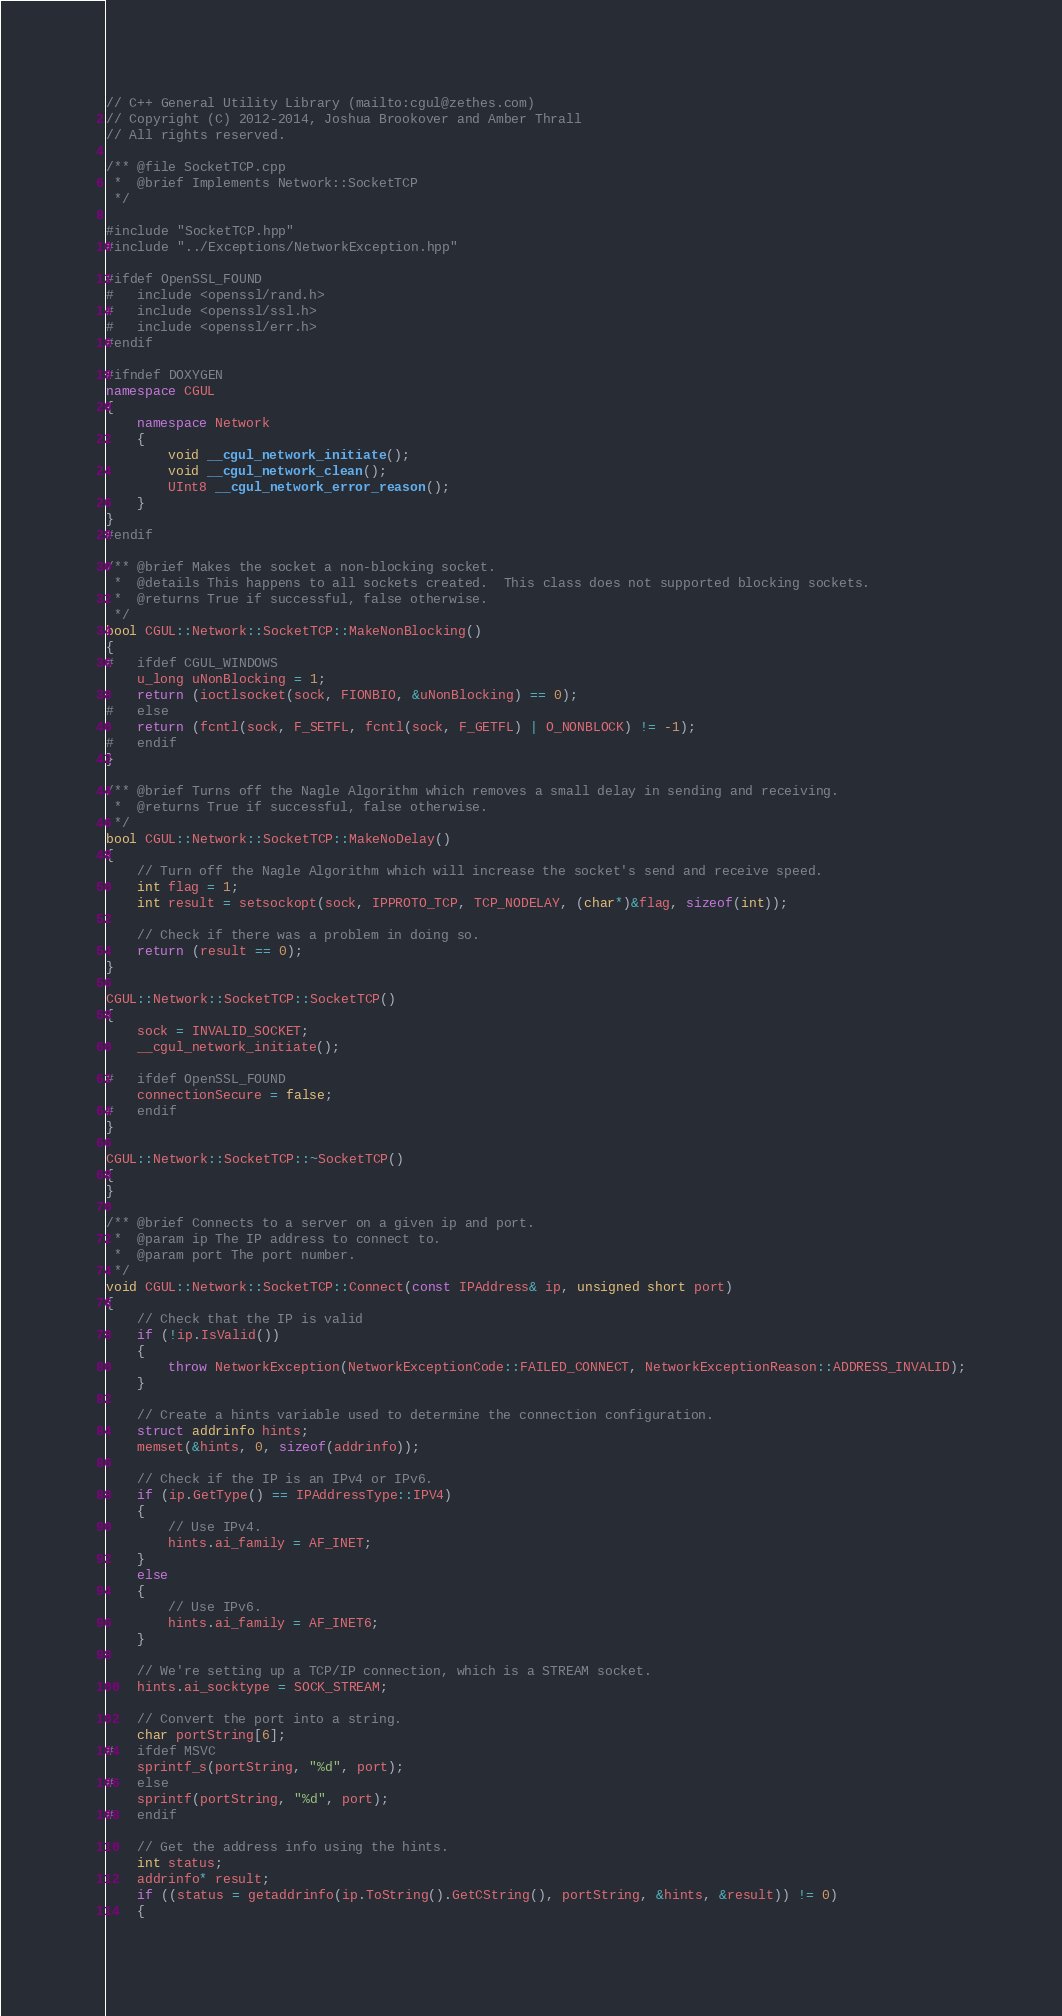<code> <loc_0><loc_0><loc_500><loc_500><_C++_>// C++ General Utility Library (mailto:cgul@zethes.com)
// Copyright (C) 2012-2014, Joshua Brookover and Amber Thrall
// All rights reserved.

/** @file SocketTCP.cpp
 *  @brief Implements Network::SocketTCP
 */

#include "SocketTCP.hpp"
#include "../Exceptions/NetworkException.hpp"

#ifdef OpenSSL_FOUND
#   include <openssl/rand.h>
#   include <openssl/ssl.h>
#   include <openssl/err.h>
#endif

#ifndef DOXYGEN
namespace CGUL
{
    namespace Network
    {
        void __cgul_network_initiate();
        void __cgul_network_clean();
        UInt8 __cgul_network_error_reason();
    }
}
#endif

/** @brief Makes the socket a non-blocking socket.
 *  @details This happens to all sockets created.  This class does not supported blocking sockets.
 *  @returns True if successful, false otherwise.
 */
bool CGUL::Network::SocketTCP::MakeNonBlocking()
{
#   ifdef CGUL_WINDOWS
    u_long uNonBlocking = 1;
    return (ioctlsocket(sock, FIONBIO, &uNonBlocking) == 0);
#   else
    return (fcntl(sock, F_SETFL, fcntl(sock, F_GETFL) | O_NONBLOCK) != -1);
#   endif
}

/** @brief Turns off the Nagle Algorithm which removes a small delay in sending and receiving.
 *  @returns True if successful, false otherwise.
 */
bool CGUL::Network::SocketTCP::MakeNoDelay()
{
    // Turn off the Nagle Algorithm which will increase the socket's send and receive speed.
    int flag = 1;
    int result = setsockopt(sock, IPPROTO_TCP, TCP_NODELAY, (char*)&flag, sizeof(int));

    // Check if there was a problem in doing so.
    return (result == 0);
}

CGUL::Network::SocketTCP::SocketTCP()
{
    sock = INVALID_SOCKET;
    __cgul_network_initiate();

#   ifdef OpenSSL_FOUND
    connectionSecure = false;
#   endif
}

CGUL::Network::SocketTCP::~SocketTCP()
{
}

/** @brief Connects to a server on a given ip and port.
 *  @param ip The IP address to connect to.
 *  @param port The port number.
 */
void CGUL::Network::SocketTCP::Connect(const IPAddress& ip, unsigned short port)
{
    // Check that the IP is valid
    if (!ip.IsValid())
    {
        throw NetworkException(NetworkExceptionCode::FAILED_CONNECT, NetworkExceptionReason::ADDRESS_INVALID);
    }

    // Create a hints variable used to determine the connection configuration.
    struct addrinfo hints;
    memset(&hints, 0, sizeof(addrinfo));

    // Check if the IP is an IPv4 or IPv6.
    if (ip.GetType() == IPAddressType::IPV4)
    {
        // Use IPv4.
        hints.ai_family = AF_INET;
    }
    else
    {
        // Use IPv6.
        hints.ai_family = AF_INET6;
    }

    // We're setting up a TCP/IP connection, which is a STREAM socket.
    hints.ai_socktype = SOCK_STREAM;

    // Convert the port into a string.
    char portString[6];
#   ifdef MSVC
    sprintf_s(portString, "%d", port);
#   else
    sprintf(portString, "%d", port);
#   endif

    // Get the address info using the hints.
    int status;
    addrinfo* result;
    if ((status = getaddrinfo(ip.ToString().GetCString(), portString, &hints, &result)) != 0)
    {</code> 